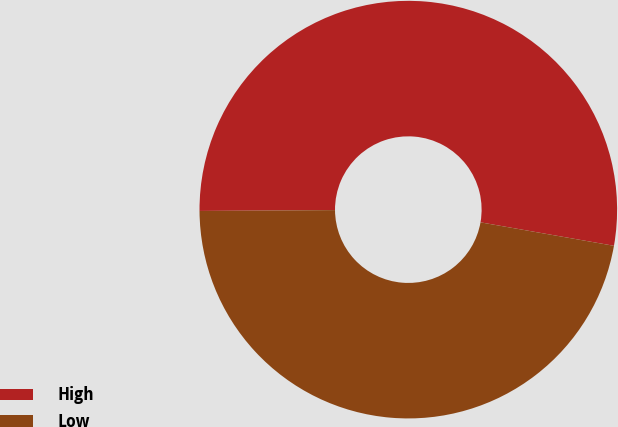Convert chart. <chart><loc_0><loc_0><loc_500><loc_500><pie_chart><fcel>High<fcel>Low<nl><fcel>52.87%<fcel>47.13%<nl></chart> 